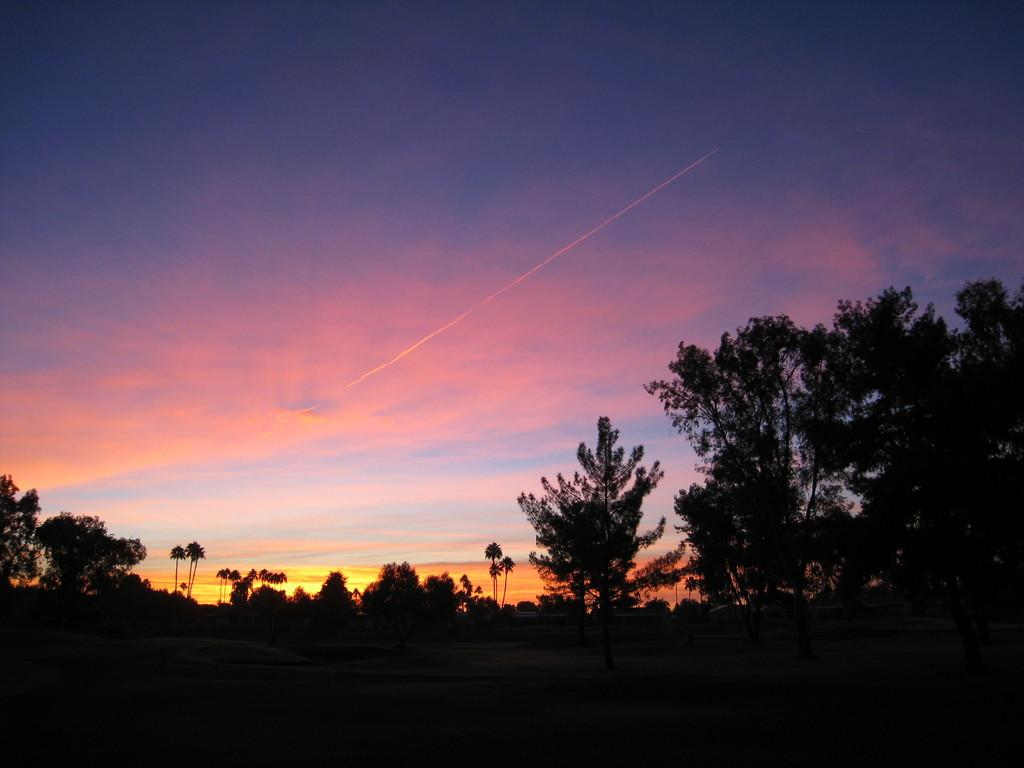What type of vegetation is present in the image? There are many trees in the image. What type of structures can be seen in the image? There are houses in the image. What part of the natural environment is visible in the image? The ground is visible in the image. What is visible in the background of the image? The sky is visible in the background of the image. Who won the competition between the son and the trees in the image? There is no competition or son present in the image; it features trees and houses. What caused the trees to grow in the image? The facts provided do not mention the cause of the trees' growth; they only indicate that there are many trees in the image. 